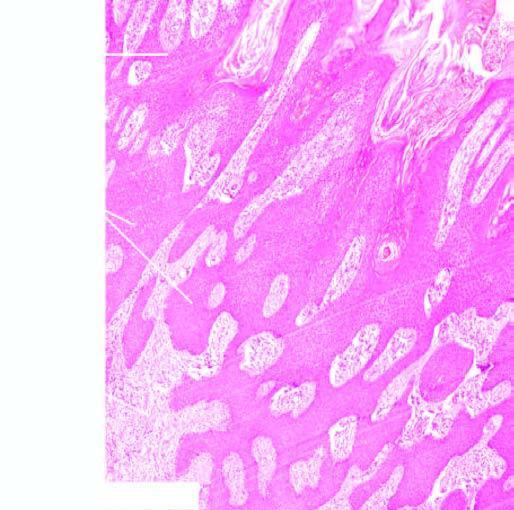does the intervening dermal soft tissue show moderate chronic inflammation?
Answer the question using a single word or phrase. Yes 